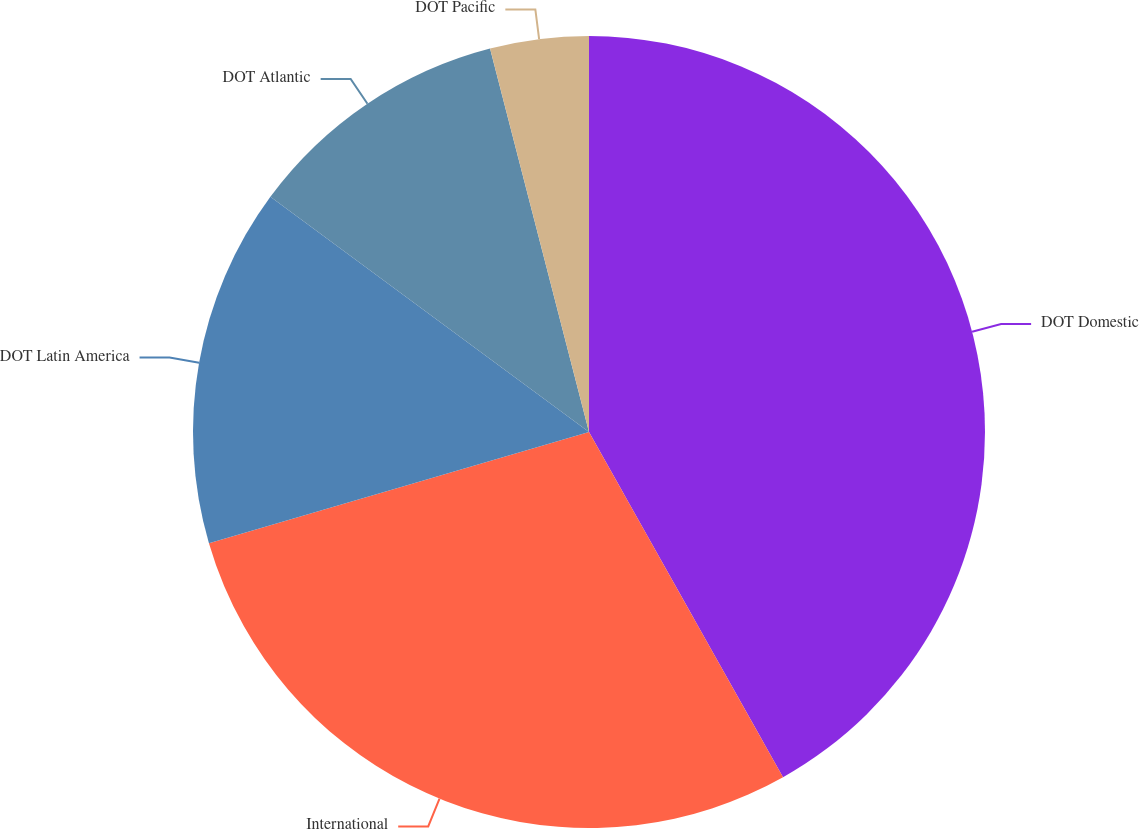Convert chart to OTSL. <chart><loc_0><loc_0><loc_500><loc_500><pie_chart><fcel>DOT Domestic<fcel>International<fcel>DOT Latin America<fcel>DOT Atlantic<fcel>DOT Pacific<nl><fcel>41.85%<fcel>28.62%<fcel>14.65%<fcel>10.86%<fcel>4.02%<nl></chart> 